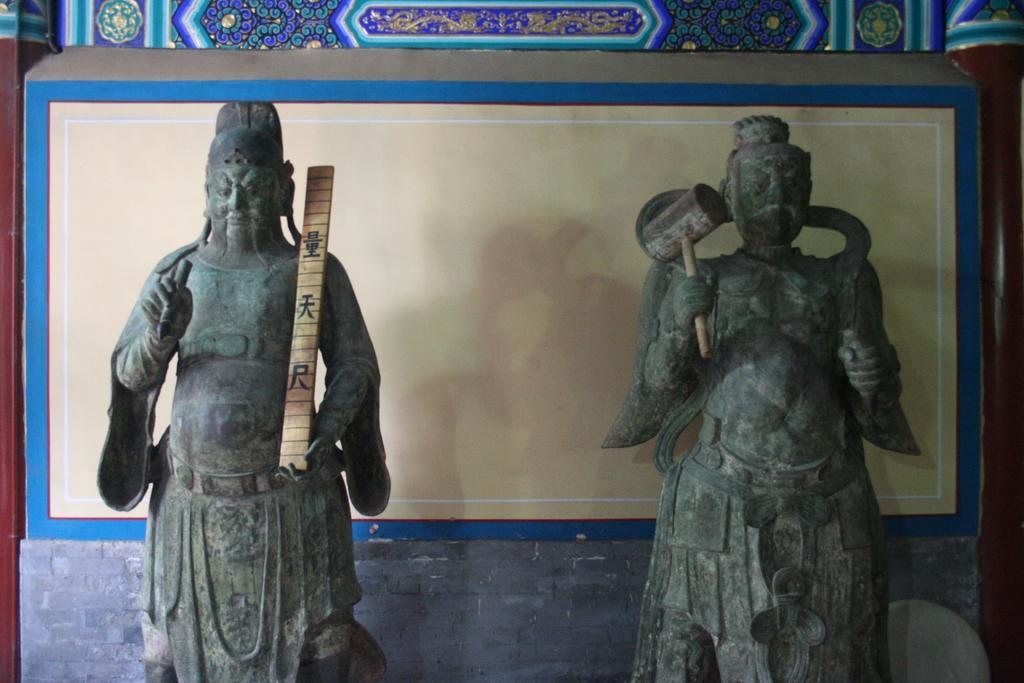Please provide a concise description of this image. In this picture we can see couple of sculptures. 